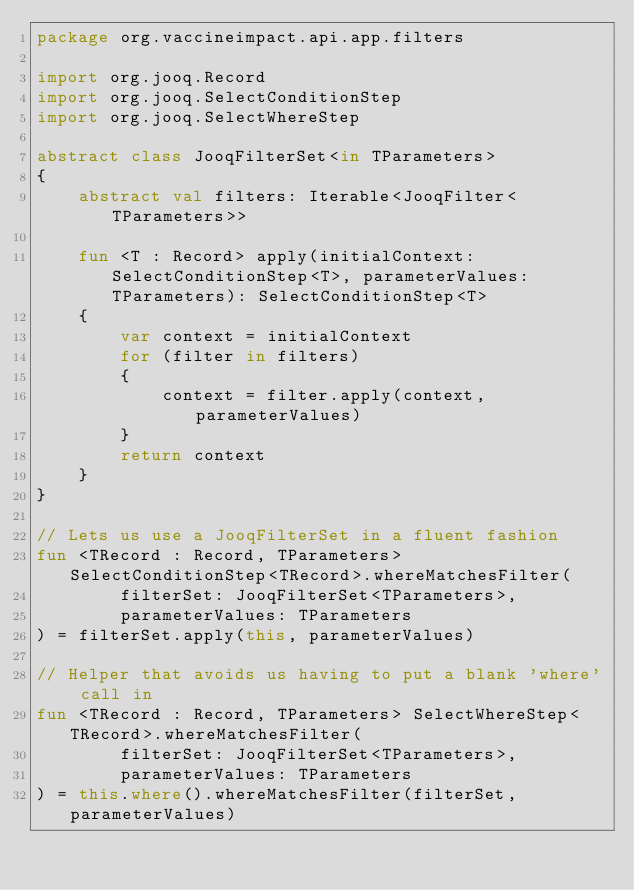Convert code to text. <code><loc_0><loc_0><loc_500><loc_500><_Kotlin_>package org.vaccineimpact.api.app.filters

import org.jooq.Record
import org.jooq.SelectConditionStep
import org.jooq.SelectWhereStep

abstract class JooqFilterSet<in TParameters>
{
    abstract val filters: Iterable<JooqFilter<TParameters>>

    fun <T : Record> apply(initialContext: SelectConditionStep<T>, parameterValues: TParameters): SelectConditionStep<T>
    {
        var context = initialContext
        for (filter in filters)
        {
            context = filter.apply(context, parameterValues)
        }
        return context
    }
}

// Lets us use a JooqFilterSet in a fluent fashion
fun <TRecord : Record, TParameters> SelectConditionStep<TRecord>.whereMatchesFilter(
        filterSet: JooqFilterSet<TParameters>,
        parameterValues: TParameters
) = filterSet.apply(this, parameterValues)

// Helper that avoids us having to put a blank 'where' call in
fun <TRecord : Record, TParameters> SelectWhereStep<TRecord>.whereMatchesFilter(
        filterSet: JooqFilterSet<TParameters>,
        parameterValues: TParameters
) = this.where().whereMatchesFilter(filterSet, parameterValues)</code> 